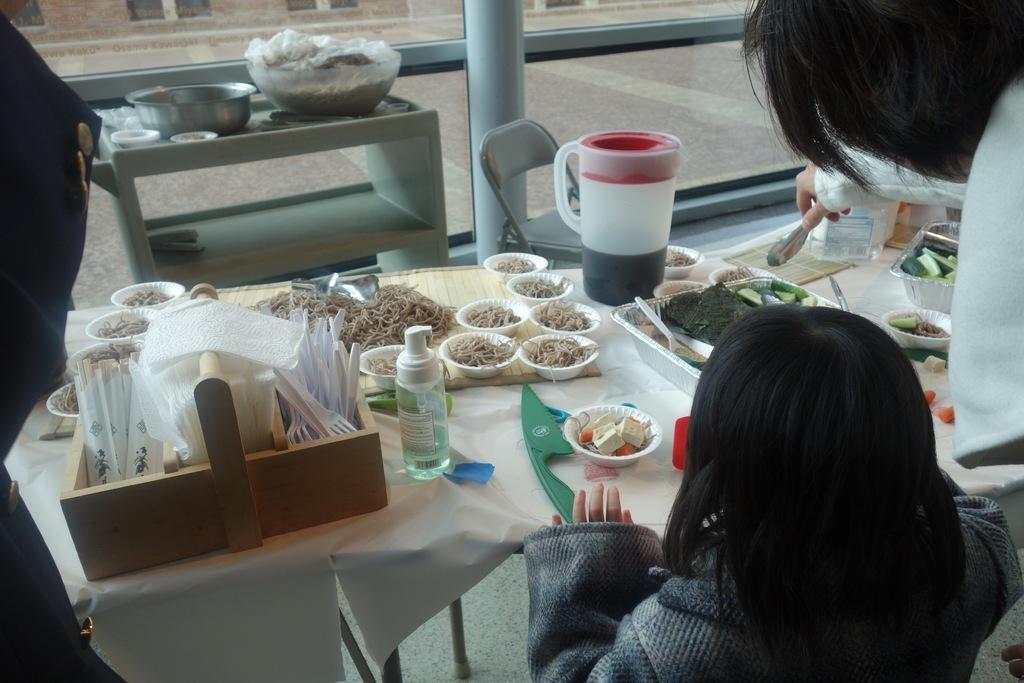Could you give a brief overview of what you see in this image? There is a girl sitting at the dining table where there is food served and tray of tissues on it. On the other side there is other woman serving food to the girl. 